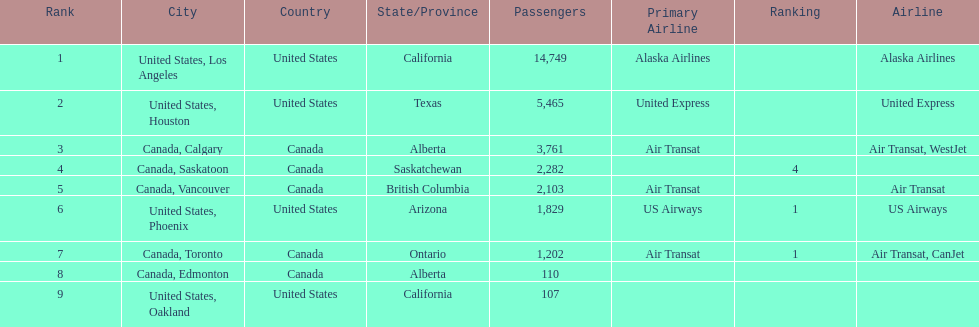What was the number of passengers in phoenix arizona? 1,829. 